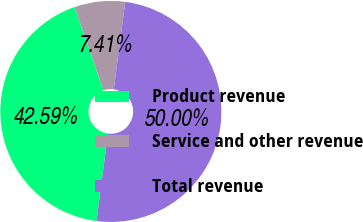Convert chart. <chart><loc_0><loc_0><loc_500><loc_500><pie_chart><fcel>Product revenue<fcel>Service and other revenue<fcel>Total revenue<nl><fcel>42.59%<fcel>7.41%<fcel>50.0%<nl></chart> 